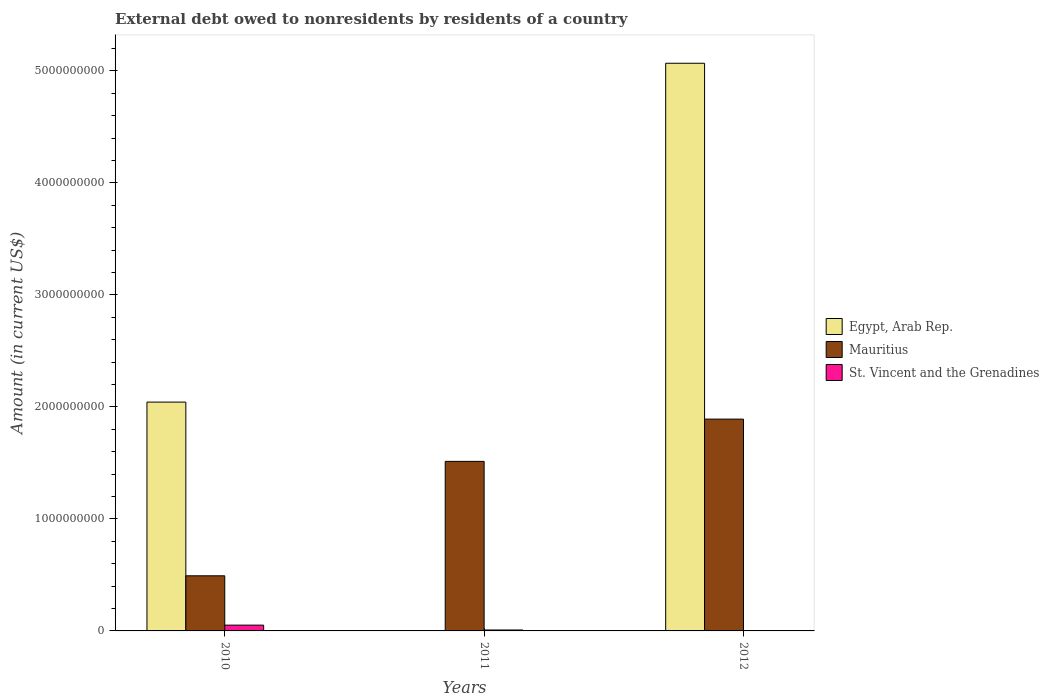How many groups of bars are there?
Your answer should be very brief. 3. Are the number of bars on each tick of the X-axis equal?
Your response must be concise. No. How many bars are there on the 1st tick from the right?
Keep it short and to the point. 2. What is the label of the 1st group of bars from the left?
Your answer should be compact. 2010. What is the external debt owed by residents in Mauritius in 2010?
Give a very brief answer. 4.92e+08. Across all years, what is the maximum external debt owed by residents in Mauritius?
Your response must be concise. 1.89e+09. Across all years, what is the minimum external debt owed by residents in St. Vincent and the Grenadines?
Keep it short and to the point. 0. What is the total external debt owed by residents in St. Vincent and the Grenadines in the graph?
Offer a very short reply. 5.99e+07. What is the difference between the external debt owed by residents in Mauritius in 2011 and that in 2012?
Provide a short and direct response. -3.77e+08. What is the difference between the external debt owed by residents in Egypt, Arab Rep. in 2011 and the external debt owed by residents in Mauritius in 2010?
Keep it short and to the point. -4.92e+08. What is the average external debt owed by residents in Egypt, Arab Rep. per year?
Your response must be concise. 2.37e+09. In the year 2010, what is the difference between the external debt owed by residents in St. Vincent and the Grenadines and external debt owed by residents in Mauritius?
Your answer should be compact. -4.40e+08. What is the ratio of the external debt owed by residents in Mauritius in 2011 to that in 2012?
Ensure brevity in your answer.  0.8. Is the difference between the external debt owed by residents in St. Vincent and the Grenadines in 2010 and 2011 greater than the difference between the external debt owed by residents in Mauritius in 2010 and 2011?
Your answer should be very brief. Yes. What is the difference between the highest and the second highest external debt owed by residents in Mauritius?
Ensure brevity in your answer.  3.77e+08. What is the difference between the highest and the lowest external debt owed by residents in Egypt, Arab Rep.?
Provide a succinct answer. 5.07e+09. Are all the bars in the graph horizontal?
Your response must be concise. No. Are the values on the major ticks of Y-axis written in scientific E-notation?
Provide a short and direct response. No. Does the graph contain any zero values?
Provide a succinct answer. Yes. Where does the legend appear in the graph?
Your answer should be very brief. Center right. How are the legend labels stacked?
Your response must be concise. Vertical. What is the title of the graph?
Provide a short and direct response. External debt owed to nonresidents by residents of a country. Does "Benin" appear as one of the legend labels in the graph?
Provide a succinct answer. No. What is the Amount (in current US$) of Egypt, Arab Rep. in 2010?
Provide a short and direct response. 2.04e+09. What is the Amount (in current US$) in Mauritius in 2010?
Keep it short and to the point. 4.92e+08. What is the Amount (in current US$) of St. Vincent and the Grenadines in 2010?
Keep it short and to the point. 5.17e+07. What is the Amount (in current US$) of Egypt, Arab Rep. in 2011?
Keep it short and to the point. 0. What is the Amount (in current US$) of Mauritius in 2011?
Your response must be concise. 1.51e+09. What is the Amount (in current US$) in St. Vincent and the Grenadines in 2011?
Ensure brevity in your answer.  8.28e+06. What is the Amount (in current US$) in Egypt, Arab Rep. in 2012?
Provide a succinct answer. 5.07e+09. What is the Amount (in current US$) in Mauritius in 2012?
Offer a very short reply. 1.89e+09. Across all years, what is the maximum Amount (in current US$) of Egypt, Arab Rep.?
Ensure brevity in your answer.  5.07e+09. Across all years, what is the maximum Amount (in current US$) of Mauritius?
Offer a very short reply. 1.89e+09. Across all years, what is the maximum Amount (in current US$) in St. Vincent and the Grenadines?
Your response must be concise. 5.17e+07. Across all years, what is the minimum Amount (in current US$) in Mauritius?
Offer a terse response. 4.92e+08. What is the total Amount (in current US$) in Egypt, Arab Rep. in the graph?
Provide a short and direct response. 7.11e+09. What is the total Amount (in current US$) in Mauritius in the graph?
Provide a short and direct response. 3.90e+09. What is the total Amount (in current US$) of St. Vincent and the Grenadines in the graph?
Make the answer very short. 5.99e+07. What is the difference between the Amount (in current US$) of Mauritius in 2010 and that in 2011?
Your answer should be compact. -1.02e+09. What is the difference between the Amount (in current US$) in St. Vincent and the Grenadines in 2010 and that in 2011?
Make the answer very short. 4.34e+07. What is the difference between the Amount (in current US$) in Egypt, Arab Rep. in 2010 and that in 2012?
Provide a succinct answer. -3.02e+09. What is the difference between the Amount (in current US$) in Mauritius in 2010 and that in 2012?
Your answer should be very brief. -1.40e+09. What is the difference between the Amount (in current US$) in Mauritius in 2011 and that in 2012?
Your answer should be very brief. -3.77e+08. What is the difference between the Amount (in current US$) in Egypt, Arab Rep. in 2010 and the Amount (in current US$) in Mauritius in 2011?
Make the answer very short. 5.29e+08. What is the difference between the Amount (in current US$) in Egypt, Arab Rep. in 2010 and the Amount (in current US$) in St. Vincent and the Grenadines in 2011?
Provide a succinct answer. 2.03e+09. What is the difference between the Amount (in current US$) in Mauritius in 2010 and the Amount (in current US$) in St. Vincent and the Grenadines in 2011?
Your answer should be very brief. 4.84e+08. What is the difference between the Amount (in current US$) of Egypt, Arab Rep. in 2010 and the Amount (in current US$) of Mauritius in 2012?
Ensure brevity in your answer.  1.52e+08. What is the average Amount (in current US$) of Egypt, Arab Rep. per year?
Provide a succinct answer. 2.37e+09. What is the average Amount (in current US$) of Mauritius per year?
Keep it short and to the point. 1.30e+09. What is the average Amount (in current US$) in St. Vincent and the Grenadines per year?
Provide a short and direct response. 2.00e+07. In the year 2010, what is the difference between the Amount (in current US$) of Egypt, Arab Rep. and Amount (in current US$) of Mauritius?
Provide a short and direct response. 1.55e+09. In the year 2010, what is the difference between the Amount (in current US$) of Egypt, Arab Rep. and Amount (in current US$) of St. Vincent and the Grenadines?
Give a very brief answer. 1.99e+09. In the year 2010, what is the difference between the Amount (in current US$) in Mauritius and Amount (in current US$) in St. Vincent and the Grenadines?
Keep it short and to the point. 4.40e+08. In the year 2011, what is the difference between the Amount (in current US$) in Mauritius and Amount (in current US$) in St. Vincent and the Grenadines?
Ensure brevity in your answer.  1.51e+09. In the year 2012, what is the difference between the Amount (in current US$) in Egypt, Arab Rep. and Amount (in current US$) in Mauritius?
Your answer should be very brief. 3.18e+09. What is the ratio of the Amount (in current US$) of Mauritius in 2010 to that in 2011?
Ensure brevity in your answer.  0.33. What is the ratio of the Amount (in current US$) in St. Vincent and the Grenadines in 2010 to that in 2011?
Offer a very short reply. 6.24. What is the ratio of the Amount (in current US$) of Egypt, Arab Rep. in 2010 to that in 2012?
Provide a short and direct response. 0.4. What is the ratio of the Amount (in current US$) in Mauritius in 2010 to that in 2012?
Offer a very short reply. 0.26. What is the ratio of the Amount (in current US$) of Mauritius in 2011 to that in 2012?
Your response must be concise. 0.8. What is the difference between the highest and the second highest Amount (in current US$) of Mauritius?
Provide a short and direct response. 3.77e+08. What is the difference between the highest and the lowest Amount (in current US$) in Egypt, Arab Rep.?
Your answer should be very brief. 5.07e+09. What is the difference between the highest and the lowest Amount (in current US$) of Mauritius?
Make the answer very short. 1.40e+09. What is the difference between the highest and the lowest Amount (in current US$) of St. Vincent and the Grenadines?
Give a very brief answer. 5.17e+07. 